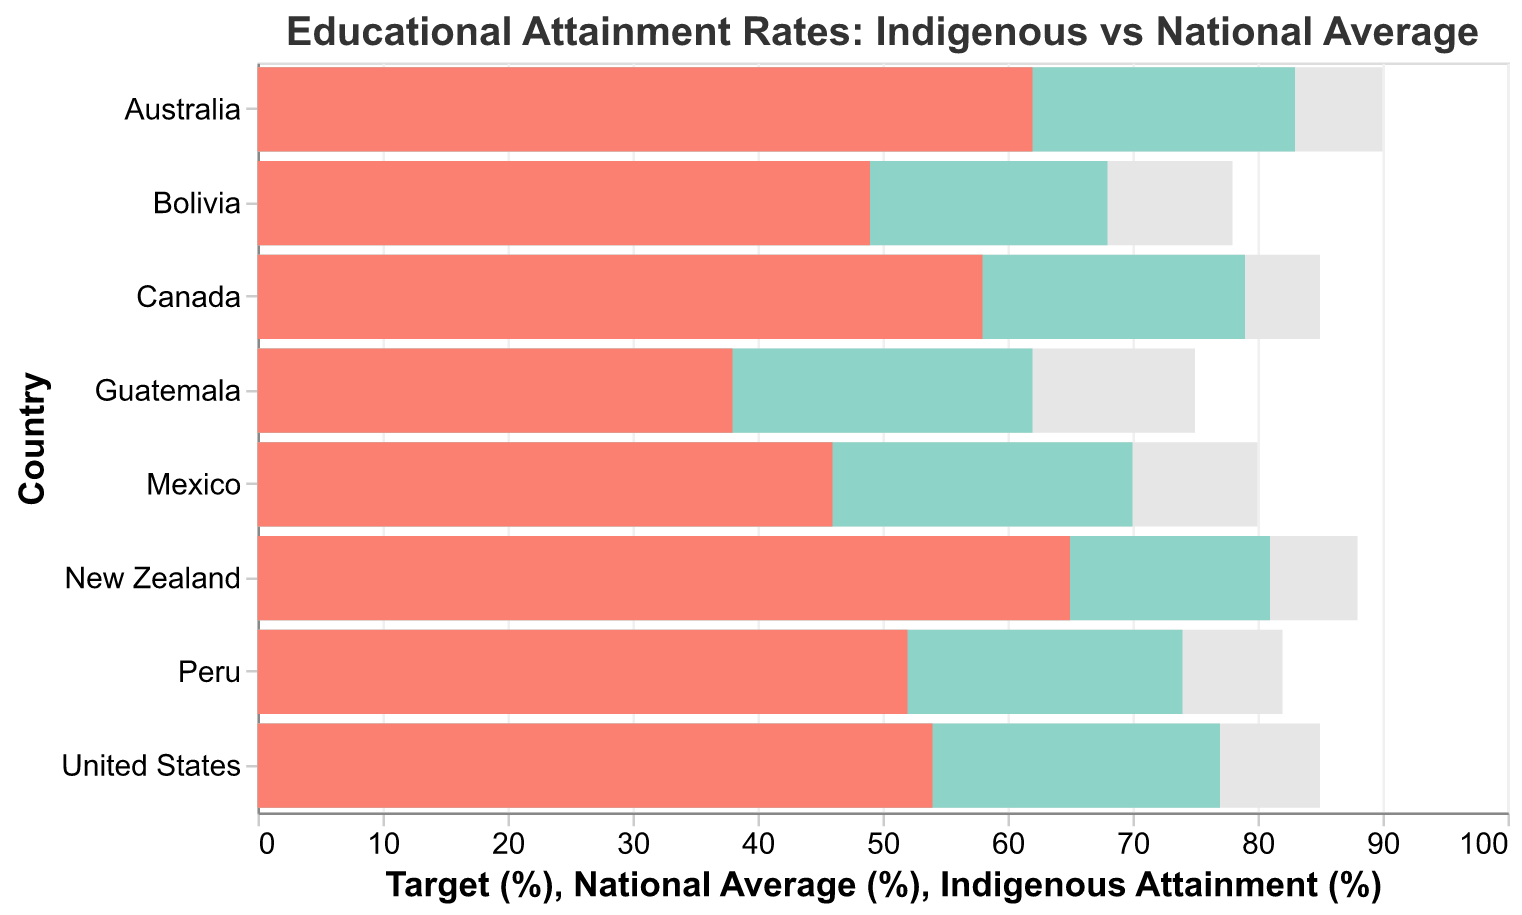What is the title of the figure? The title of the figure is usually located at the top and is rendered in larger or bold font to indicate its importance.
Answer: Educational Attainment Rates: Indigenous vs National Average How many countries are included in the figure? Count the unique country names listed on the y-axis.
Answer: 8 Which country has the highest Indigenous Attainment rate? Locate the highest bar in the Indigenous Attainment (%) series and identify its corresponding country from the y-axis.
Answer: New Zealand What is the difference between the National Average and the Indigenous Attainment rate in Canada? Subtract the Indigenous Attainment percentage from the National Average percentage for Canada.
Answer: 21 Which country has the smallest gap between Indigenous Attainment and the National Average? Calculate the difference between the National Average and Indigenous Attainment rate for each country and identify the smallest value.
Answer: New Zealand How does Australia's Indigenous Attainment rate compare to other countries? Look at the bar representing Australia's Indigenous Attainment rate and observe its relative position compared to other countries' bars.
Answer: Higher than six, lower than one What is the average Target percentage across all countries? Sum the Target percentages for all countries and divide by the number of countries. Calculate: (90+85+88+85+80+75+82+78)/8.
Answer: 81.625 Which country is furthest from its Target percentage? Calculate the difference between the Target percentage and Indigenous Attainment percentage for each country, then identify the largest value.
Answer: Guatemala What is the color representation of the Indigenous Attainment rate in the figure? Identify the color used for the bars representing the Indigenous Attainment rate. Check the color key provided or observe the bar color.
Answer: A shade of red (#fb8072) How many countries have a National Average above 75%? Count the number of countries with a National Average percentage greater than 75.
Answer: 6 